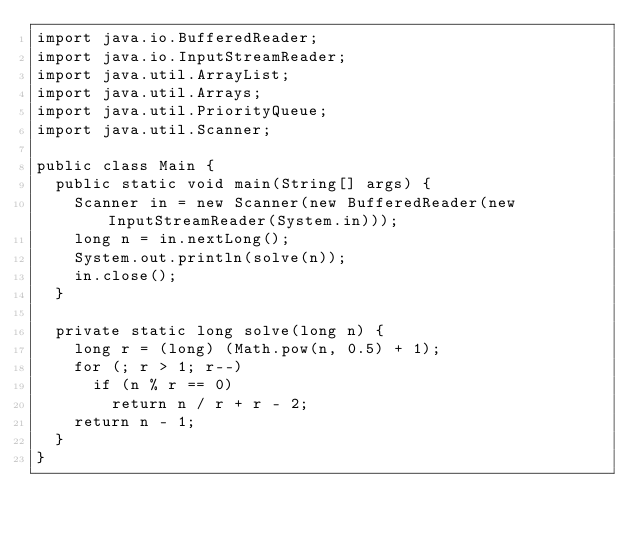<code> <loc_0><loc_0><loc_500><loc_500><_Java_>import java.io.BufferedReader;
import java.io.InputStreamReader;
import java.util.ArrayList;
import java.util.Arrays;
import java.util.PriorityQueue;
import java.util.Scanner;

public class Main {
	public static void main(String[] args) {
		Scanner in = new Scanner(new BufferedReader(new InputStreamReader(System.in)));
		long n = in.nextLong();
		System.out.println(solve(n));
		in.close();
	}

	private static long solve(long n) {
		long r = (long) (Math.pow(n, 0.5) + 1);
		for (; r > 1; r--)
			if (n % r == 0)
				return n / r + r - 2;
		return n - 1;
	}
}</code> 